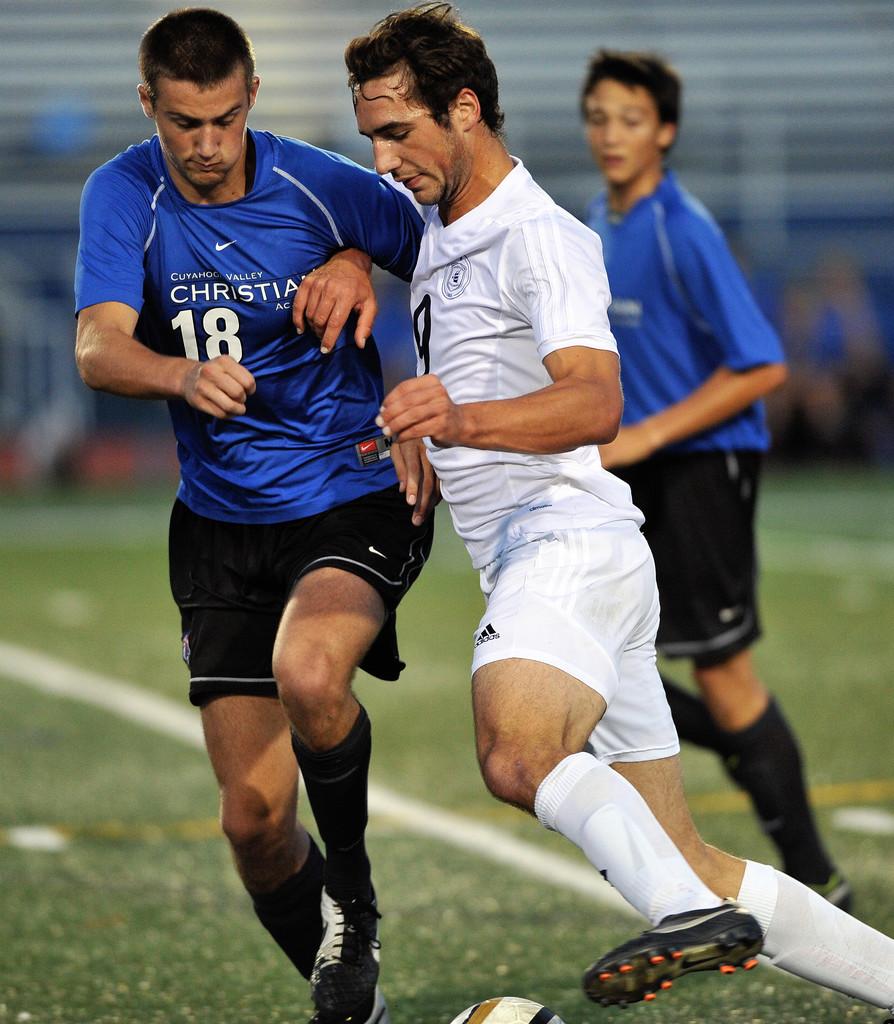What name is written on the man's blue shirt?
Offer a terse response. Christian. 